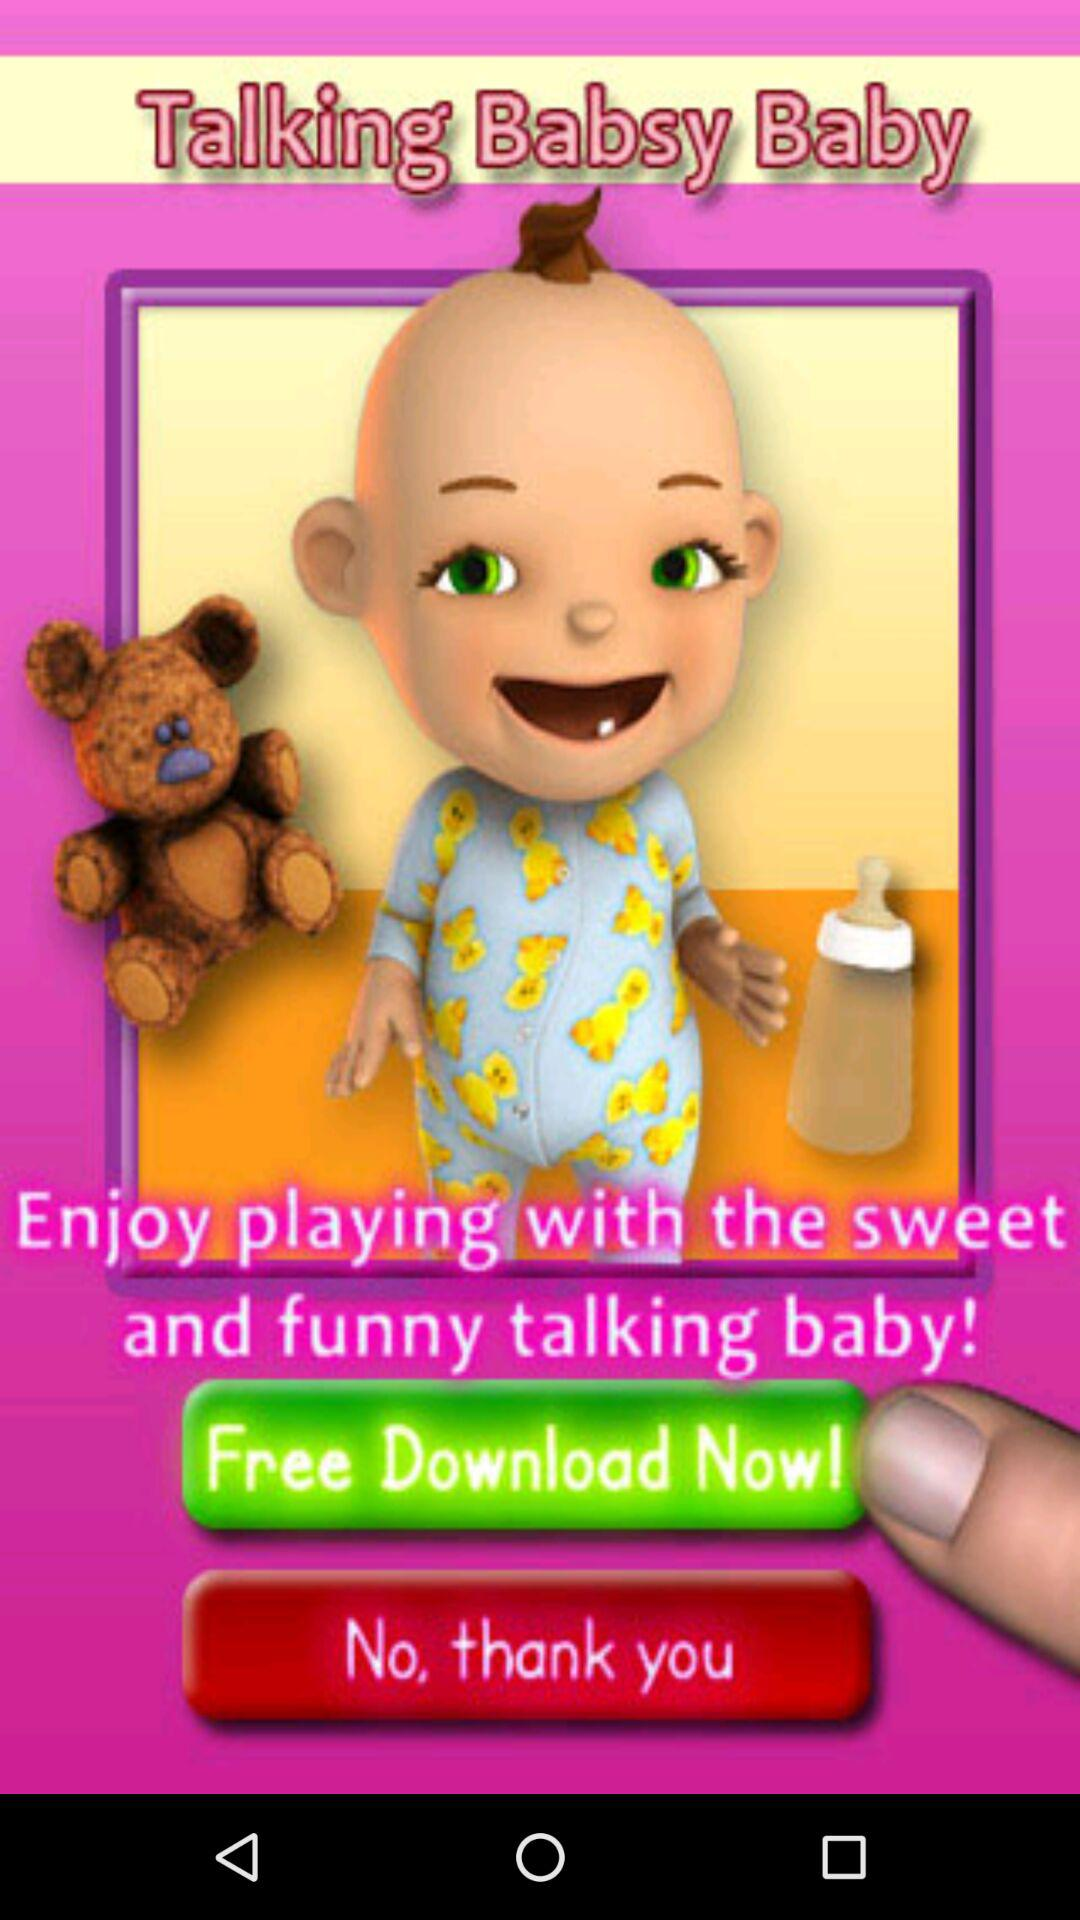What is the name of the application? The name of the application is "Talking Babsy Baby". 